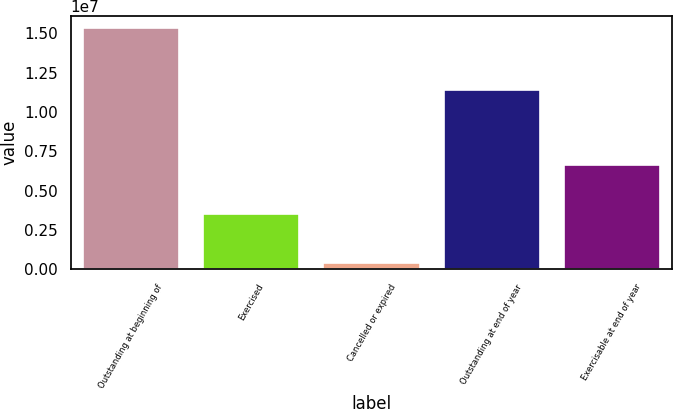<chart> <loc_0><loc_0><loc_500><loc_500><bar_chart><fcel>Outstanding at beginning of<fcel>Exercised<fcel>Cancelled or expired<fcel>Outstanding at end of year<fcel>Exercisable at end of year<nl><fcel>1.53377e+07<fcel>3.50499e+06<fcel>436750<fcel>1.13959e+07<fcel>6.64597e+06<nl></chart> 